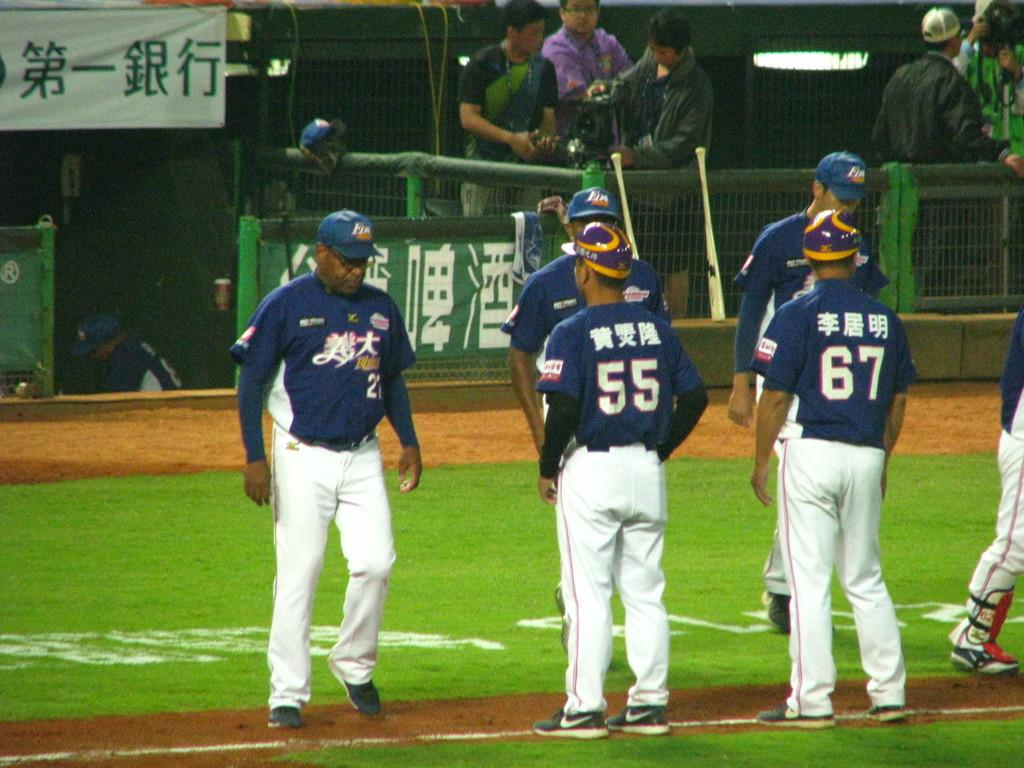<image>
Summarize the visual content of the image. A bunch of baseball players stand facing each other, including numbers 55 and 67. 